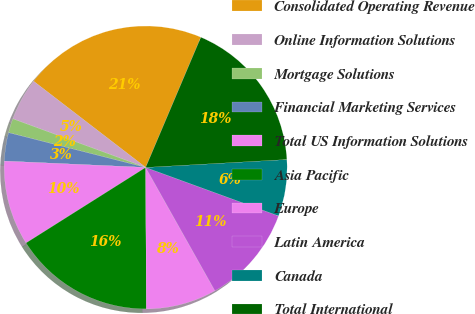Convert chart to OTSL. <chart><loc_0><loc_0><loc_500><loc_500><pie_chart><fcel>Consolidated Operating Revenue<fcel>Online Information Solutions<fcel>Mortgage Solutions<fcel>Financial Marketing Services<fcel>Total US Information Solutions<fcel>Asia Pacific<fcel>Europe<fcel>Latin America<fcel>Canada<fcel>Total International<nl><fcel>20.95%<fcel>4.85%<fcel>1.63%<fcel>3.24%<fcel>9.68%<fcel>16.12%<fcel>8.07%<fcel>11.29%<fcel>6.46%<fcel>17.73%<nl></chart> 